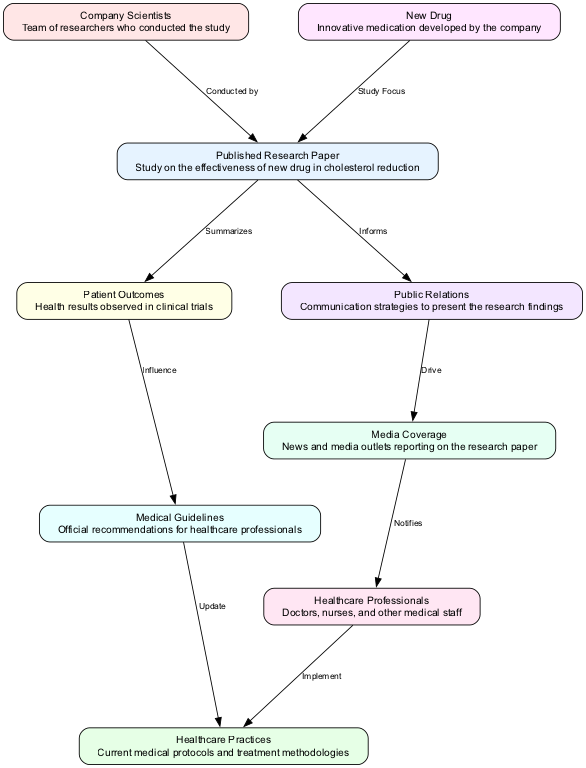What is the study focus of the research paper? The diagram indicates that the study focus of the research paper is the "New Drug," as represented by the direct link between the two nodes.
Answer: New Drug Who conducted the research paper? According to the diagram, the research paper was conducted by "Company Scientists," which can be seen in the directed edge connecting the two.
Answer: Company Scientists How many nodes are represented in the diagram? By counting the unique labeled sections in the diagram, there are 9 nodes present, each representing different aspects of the biomedical context.
Answer: 9 What influences the medical guidelines? The diagram shows a directional link stating that the "Patient Outcomes" influence the "Medical Guidelines," indicating how the results from the trials impact guidelines.
Answer: Patient Outcomes What notifies healthcare professionals about the research paper's findings? The connection between "Media Coverage" and "Healthcare Professionals" in the diagram illustrates that the media coverage notifies these professionals about the relevant information from the research paper.
Answer: Media Coverage How does the research paper inform public relations? The diagram indicates a direct link from the "Research Paper" to "Public Relations," which shows that the findings of the research paper are used to inform the strategies employed in public relations.
Answer: Informs Which node updates healthcare practices? The diagram reveals that "Medical Guidelines," through a direct relationship, update "Healthcare Practices," suggesting that new guidelines lead to changes in practices.
Answer: Medical Guidelines What summarizes the patient outcomes? The arrow leading from the "Research Paper" to "Patient Outcomes" reveals that the research paper itself summarizes the patient outcomes observed during the clinical trials.
Answer: Research Paper What role does public relations play regarding media coverage? As depicted in the diagram, the "Public Relations" node drives the "Media Coverage," indicating that the PR strategies directly influence how the research paper is reported in the media.
Answer: Drive 